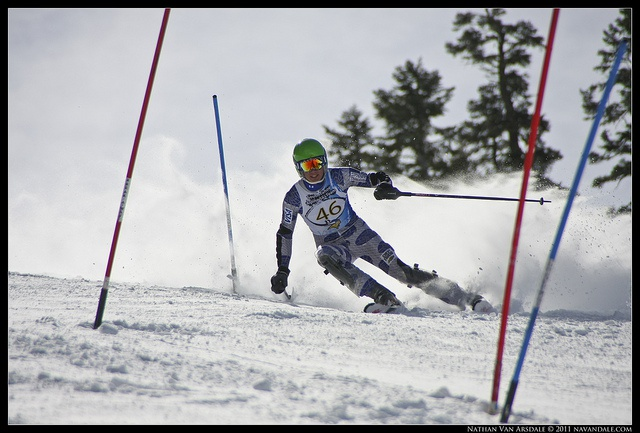Describe the objects in this image and their specific colors. I can see people in black, gray, navy, and darkgray tones and skis in black, gray, and darkgray tones in this image. 